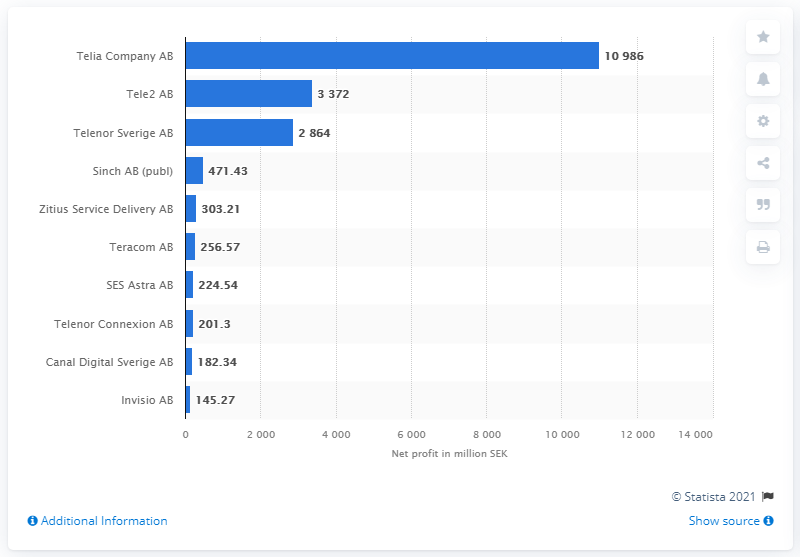Give some essential details in this illustration. Telia Company AB is the most profitable telecommunications company in Sweden as of June 2021, according to recent reports. Tele2 AB is the second most profitable telecommunications company in Sweden. 